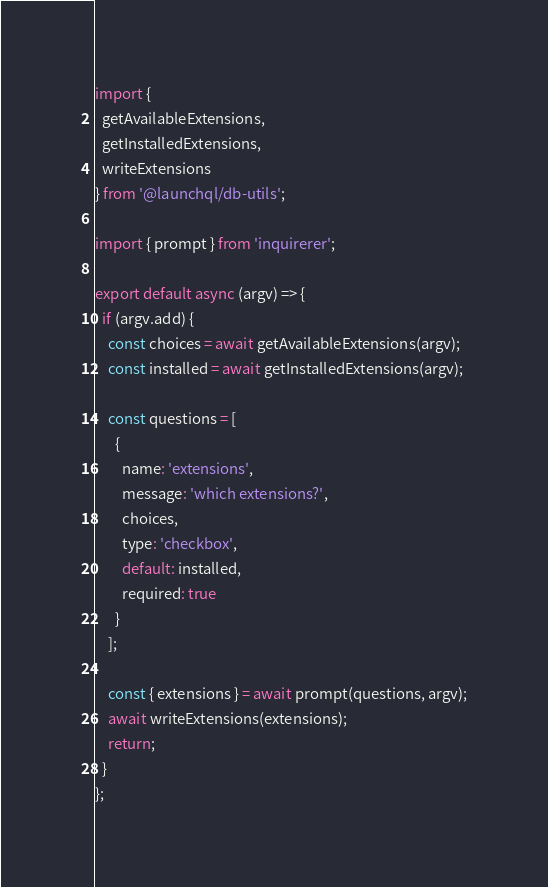<code> <loc_0><loc_0><loc_500><loc_500><_JavaScript_>import {
  getAvailableExtensions,
  getInstalledExtensions,
  writeExtensions
} from '@launchql/db-utils';

import { prompt } from 'inquirerer';

export default async (argv) => {
  if (argv.add) {
    const choices = await getAvailableExtensions(argv);
    const installed = await getInstalledExtensions(argv);

    const questions = [
      {
        name: 'extensions',
        message: 'which extensions?',
        choices,
        type: 'checkbox',
        default: installed,
        required: true
      }
    ];

    const { extensions } = await prompt(questions, argv);
    await writeExtensions(extensions);
    return;
  }
};
</code> 